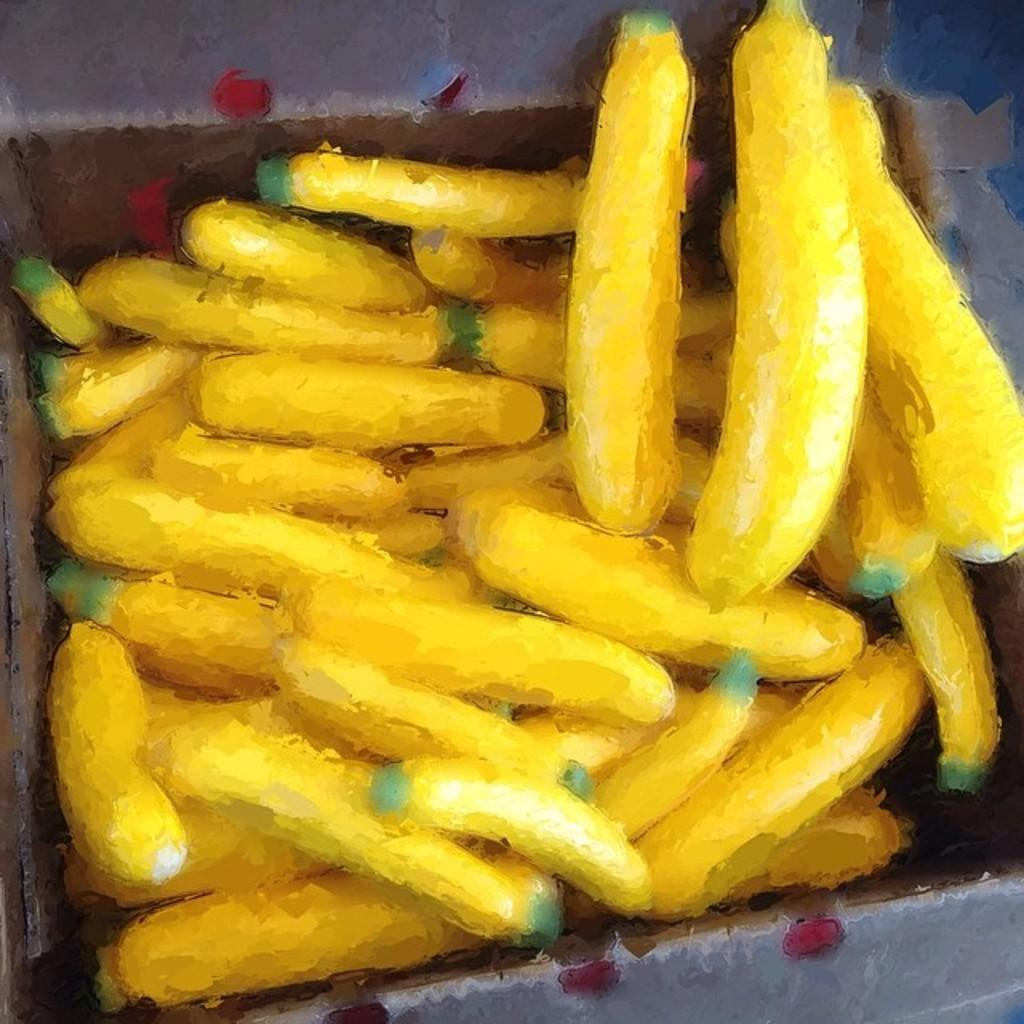What is the main subject of the image? There is a painting in the image. What does the painting depict? The painting depicts bananas. What type of pen is used to create the painting in the image? There is no pen mentioned or visible in the image; the painting is the main focus. 